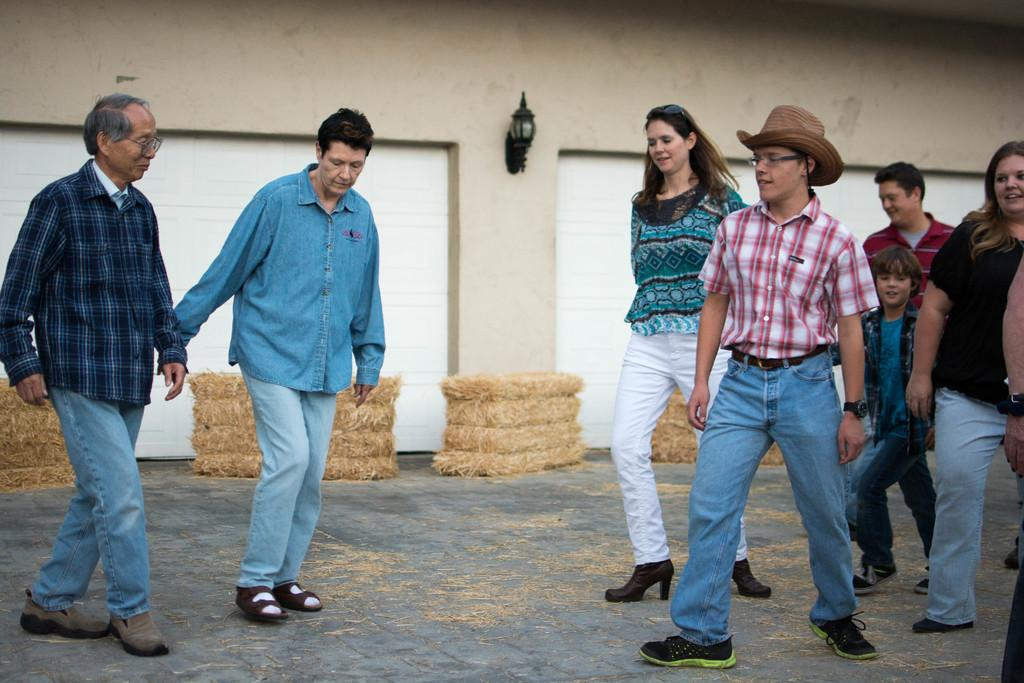How many people are in the group visible in the image? There is a group of persons in the image, but the exact number cannot be determined from the provided facts. What is the ground covered with in the image? There is dry grass on the ground in the image. What structure is present in the image? There is a wall in the image. What is attached to the wall in the image? There is a light on the wall in the image. What type of neck accessory is being worn by the person in the image? There is no information about any person wearing a neck accessory in the image. What nation is represented by the flag on the wall in the image? There is no flag present in the image. 